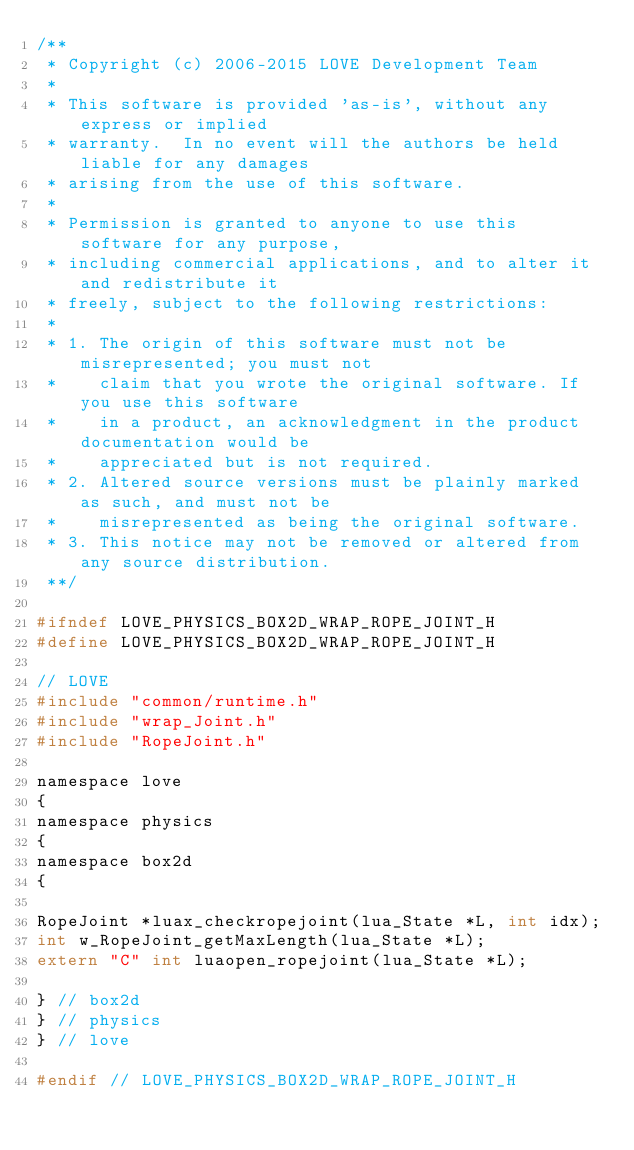Convert code to text. <code><loc_0><loc_0><loc_500><loc_500><_C_>/**
 * Copyright (c) 2006-2015 LOVE Development Team
 *
 * This software is provided 'as-is', without any express or implied
 * warranty.  In no event will the authors be held liable for any damages
 * arising from the use of this software.
 *
 * Permission is granted to anyone to use this software for any purpose,
 * including commercial applications, and to alter it and redistribute it
 * freely, subject to the following restrictions:
 *
 * 1. The origin of this software must not be misrepresented; you must not
 *    claim that you wrote the original software. If you use this software
 *    in a product, an acknowledgment in the product documentation would be
 *    appreciated but is not required.
 * 2. Altered source versions must be plainly marked as such, and must not be
 *    misrepresented as being the original software.
 * 3. This notice may not be removed or altered from any source distribution.
 **/

#ifndef LOVE_PHYSICS_BOX2D_WRAP_ROPE_JOINT_H
#define LOVE_PHYSICS_BOX2D_WRAP_ROPE_JOINT_H

// LOVE
#include "common/runtime.h"
#include "wrap_Joint.h"
#include "RopeJoint.h"

namespace love
{
namespace physics
{
namespace box2d
{

RopeJoint *luax_checkropejoint(lua_State *L, int idx);
int w_RopeJoint_getMaxLength(lua_State *L);
extern "C" int luaopen_ropejoint(lua_State *L);

} // box2d
} // physics
} // love

#endif // LOVE_PHYSICS_BOX2D_WRAP_ROPE_JOINT_H
</code> 